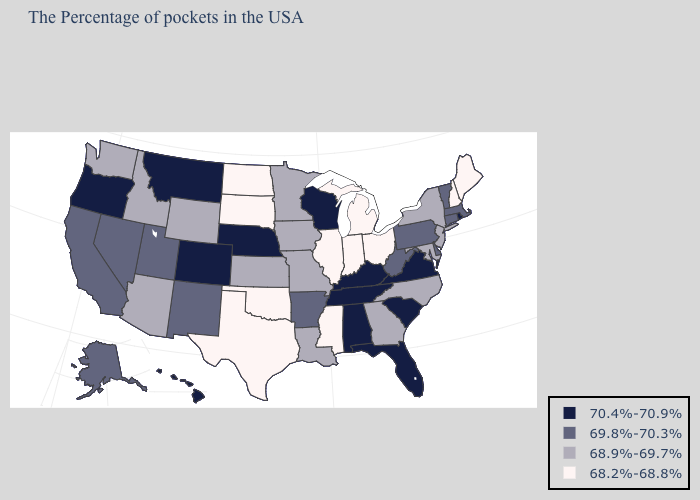Which states have the lowest value in the USA?
Short answer required. Maine, New Hampshire, Ohio, Michigan, Indiana, Illinois, Mississippi, Oklahoma, Texas, South Dakota, North Dakota. Which states have the lowest value in the South?
Write a very short answer. Mississippi, Oklahoma, Texas. What is the value of Hawaii?
Be succinct. 70.4%-70.9%. What is the value of Missouri?
Write a very short answer. 68.9%-69.7%. Name the states that have a value in the range 69.8%-70.3%?
Be succinct. Massachusetts, Vermont, Connecticut, Delaware, Pennsylvania, West Virginia, Arkansas, New Mexico, Utah, Nevada, California, Alaska. What is the value of New York?
Short answer required. 68.9%-69.7%. Which states have the lowest value in the USA?
Keep it brief. Maine, New Hampshire, Ohio, Michigan, Indiana, Illinois, Mississippi, Oklahoma, Texas, South Dakota, North Dakota. What is the value of Montana?
Concise answer only. 70.4%-70.9%. What is the value of Virginia?
Give a very brief answer. 70.4%-70.9%. Does Louisiana have the lowest value in the South?
Be succinct. No. What is the highest value in the Northeast ?
Give a very brief answer. 70.4%-70.9%. Which states have the highest value in the USA?
Give a very brief answer. Rhode Island, Virginia, South Carolina, Florida, Kentucky, Alabama, Tennessee, Wisconsin, Nebraska, Colorado, Montana, Oregon, Hawaii. Does the first symbol in the legend represent the smallest category?
Keep it brief. No. What is the value of Alabama?
Be succinct. 70.4%-70.9%. What is the value of South Dakota?
Quick response, please. 68.2%-68.8%. 